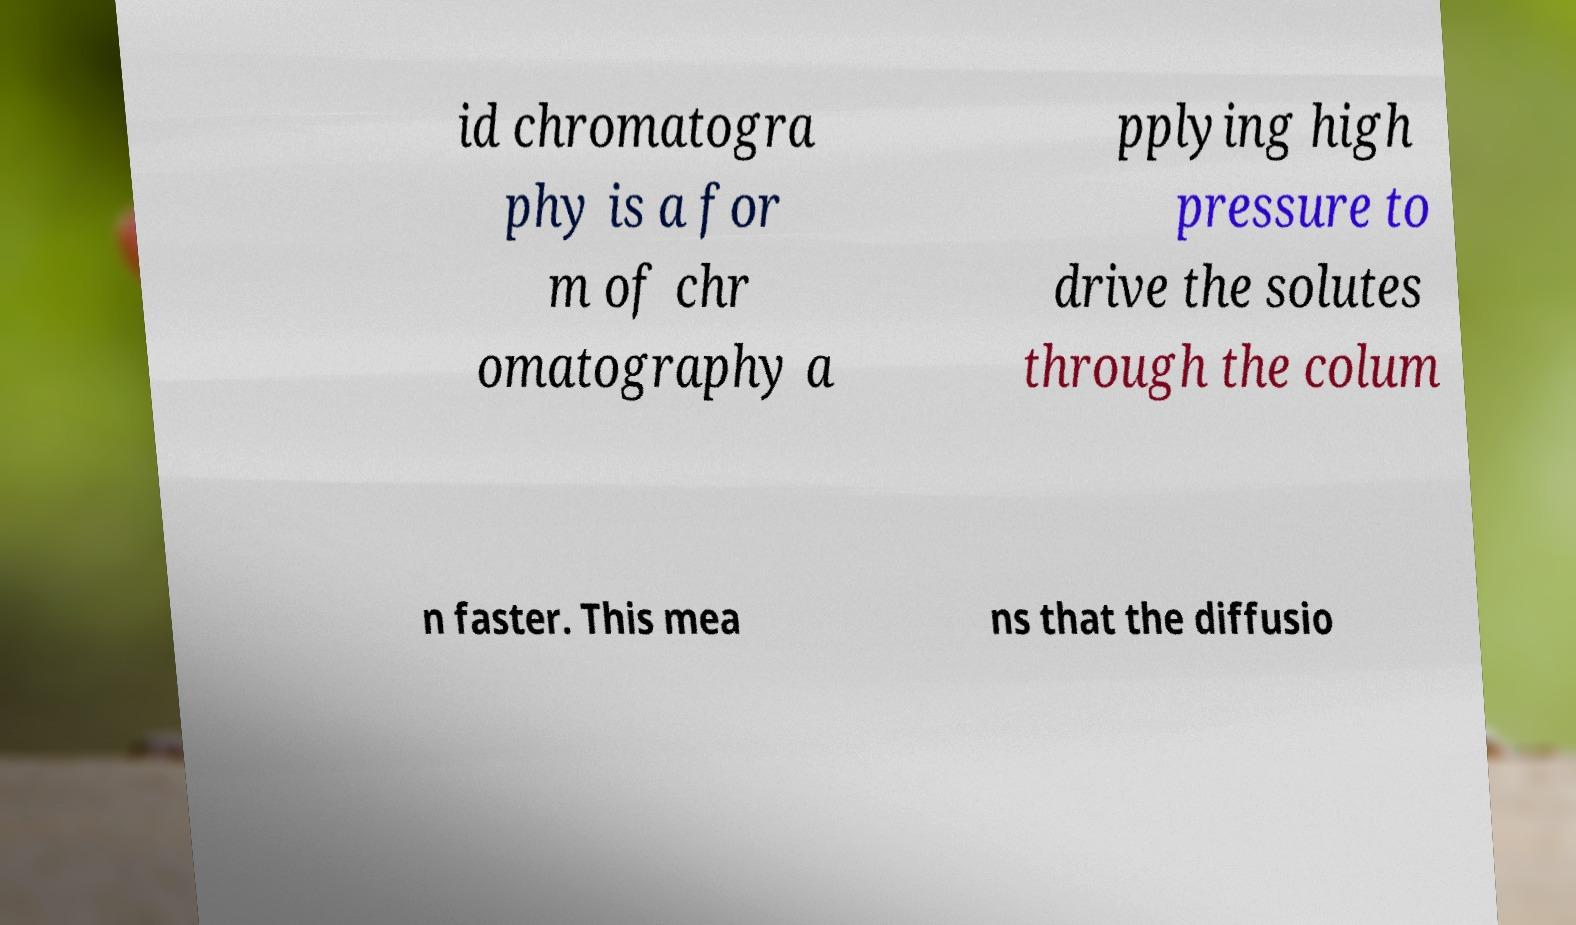I need the written content from this picture converted into text. Can you do that? id chromatogra phy is a for m of chr omatography a pplying high pressure to drive the solutes through the colum n faster. This mea ns that the diffusio 